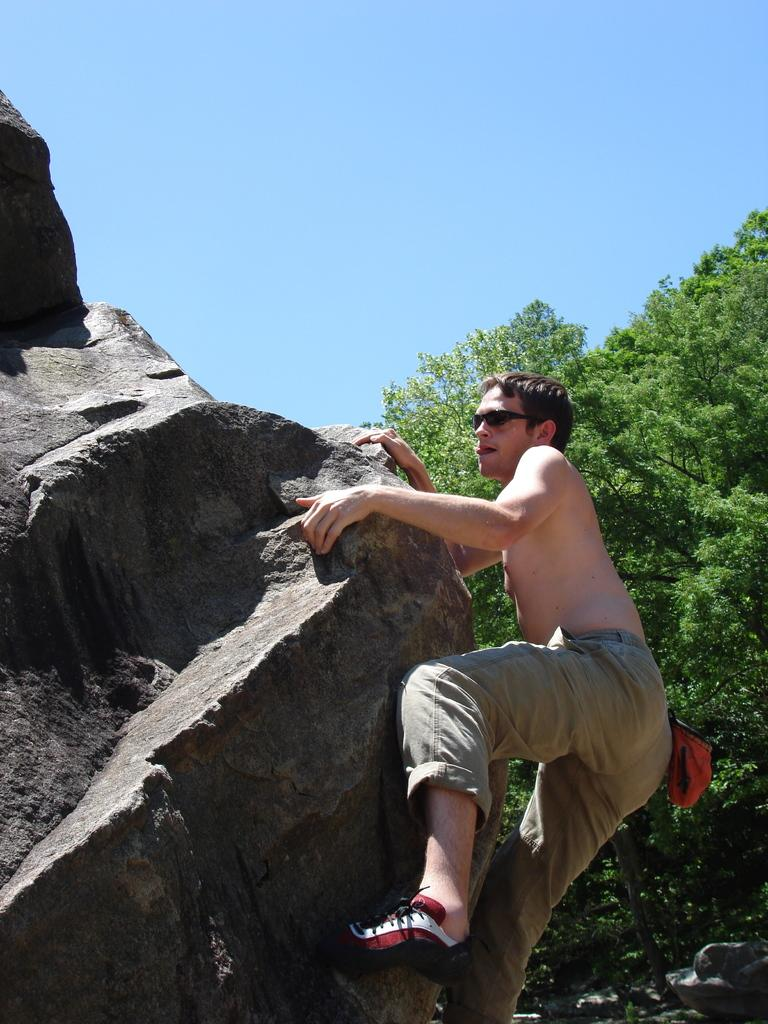What is the person in the image doing? There is a person climbing a rock in the image. What type of clothing is the person wearing? The person is wearing pants and shoes. What is the main feature in the foreground of the image? There is a big rock in the image. What can be seen in the background of the image? There is a tree and the sky visible in the background of the image. What type of loaf is the person carrying while climbing the rock? There is no loaf present in the image; the person is not carrying any such item. What route is the person taking to climb the rock? The image does not provide enough information to determine the specific route the person is taking to climb the rock. 